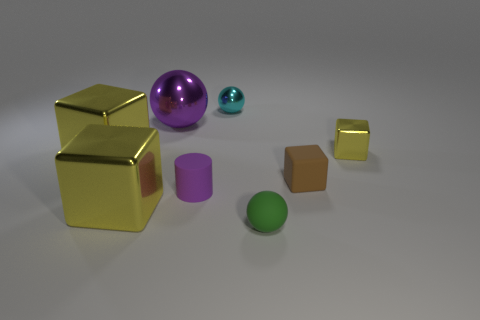Subtract all gray spheres. How many yellow blocks are left? 3 Subtract 1 blocks. How many blocks are left? 3 Add 2 yellow blocks. How many objects exist? 10 Subtract all balls. How many objects are left? 5 Add 5 cyan shiny spheres. How many cyan shiny spheres exist? 6 Subtract 0 red cubes. How many objects are left? 8 Subtract all metal objects. Subtract all cylinders. How many objects are left? 2 Add 1 small matte things. How many small matte things are left? 4 